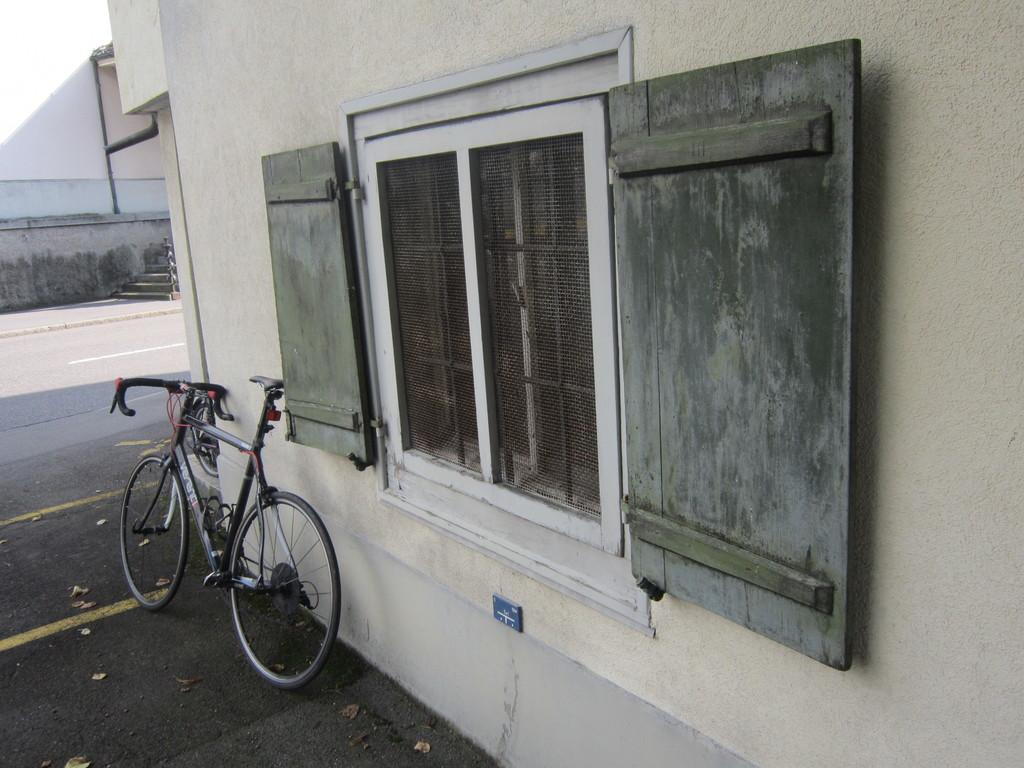What is the main mode of transportation visible in the image? There is a bicycle in the image. What type of structure can be seen in the image? There is a building in the image. What architectural feature is present in the image? There is a wall in the image. What surface is visible in the image? There is a road in the image. Where is the zoo located in the image? There is no zoo present in the image. What type of drain is visible in the image? There is no drain present in the image. 